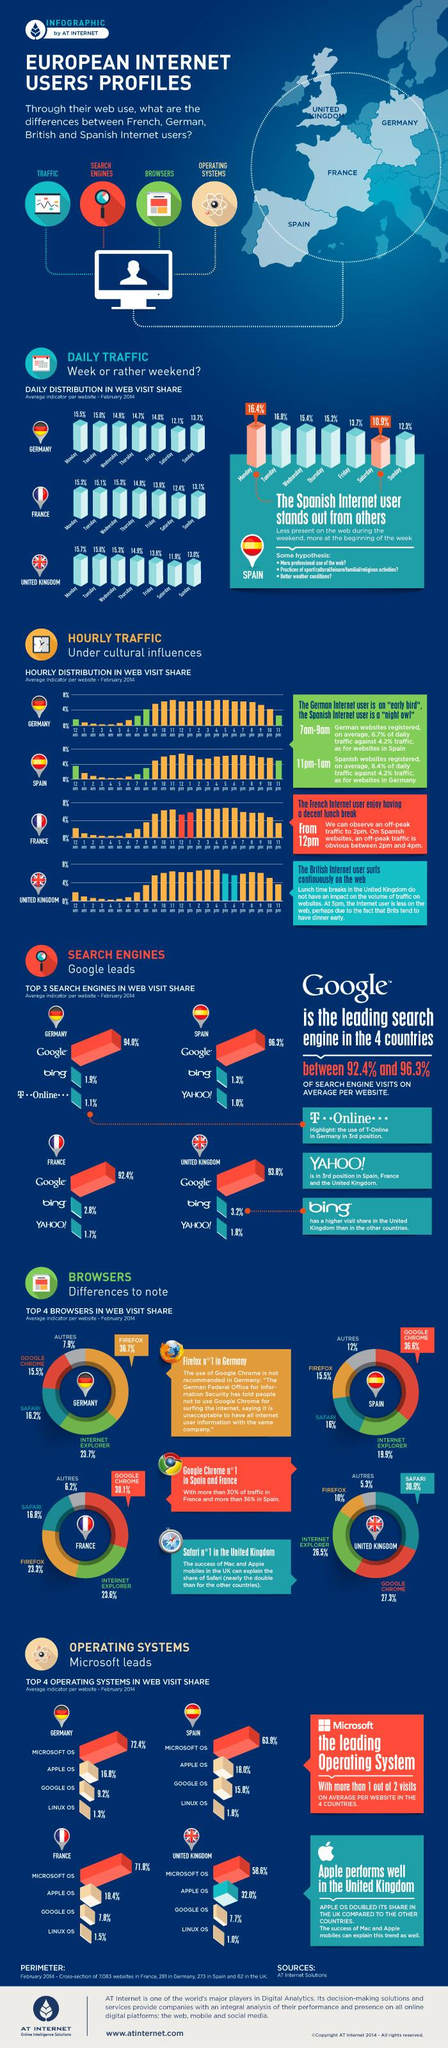Mention a couple of crucial points in this snapshot. According to the provided data, the average percentage of Google's web visit share in all four countries is 94.125%. According to the data, Bing is the second most popular search engine in terms of web visit share in all four countries. It is important to note that this data may be subject to change and may not reflect the current situation. According to the data, a majority of users, 62.9%, visit websites on Monday. The percentage of Linux OS users is 5.6%. France has an off-peak pattern from 12 pm to 2 pm. 